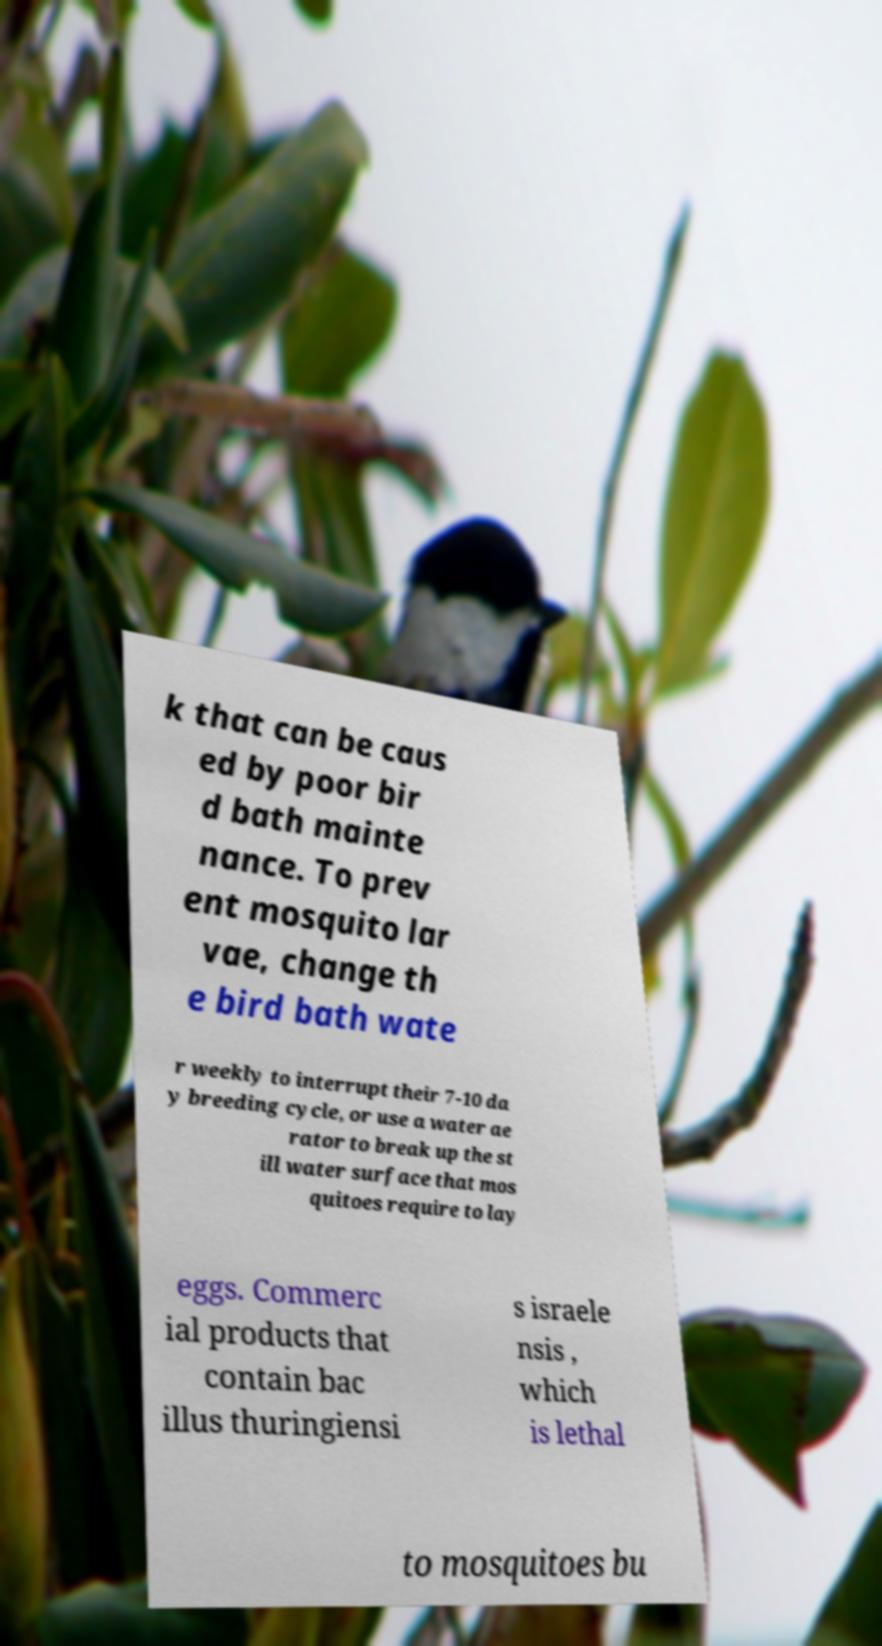Can you read and provide the text displayed in the image?This photo seems to have some interesting text. Can you extract and type it out for me? k that can be caus ed by poor bir d bath mainte nance. To prev ent mosquito lar vae, change th e bird bath wate r weekly to interrupt their 7-10 da y breeding cycle, or use a water ae rator to break up the st ill water surface that mos quitoes require to lay eggs. Commerc ial products that contain bac illus thuringiensi s israele nsis , which is lethal to mosquitoes bu 